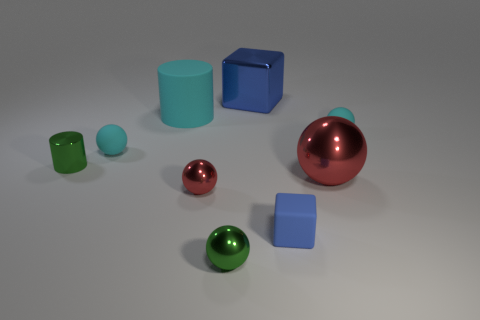Subtract all green spheres. How many spheres are left? 4 Subtract all big red metallic balls. How many balls are left? 4 Subtract all yellow balls. Subtract all red cubes. How many balls are left? 5 Subtract all blocks. How many objects are left? 7 Subtract all green metal things. Subtract all big metallic balls. How many objects are left? 6 Add 3 green spheres. How many green spheres are left? 4 Add 2 metal cubes. How many metal cubes exist? 3 Subtract 0 gray balls. How many objects are left? 9 